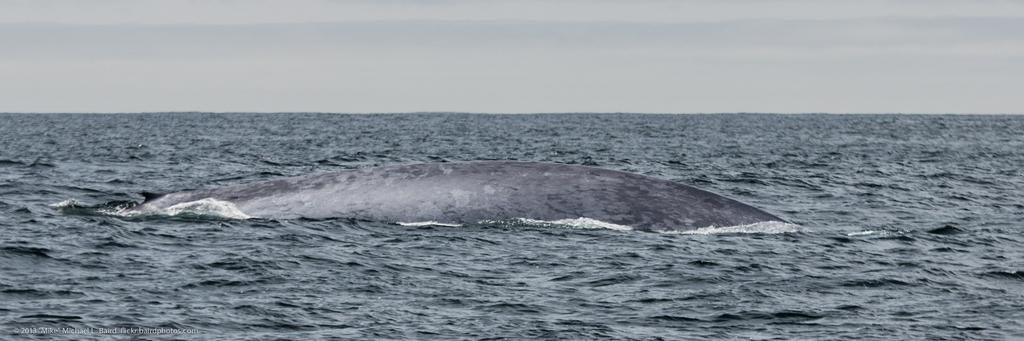What type of animal can be seen in the image? There is a sea animal in the image. Where is the sea animal located? The sea animal is in the water. What can be seen in the background of the image? The sky is visible in the background of the image. What type of knee injury can be seen on the sea animal in the image? There is no knee injury present on the sea animal in the image, as it is a sea animal and does not have knees. 